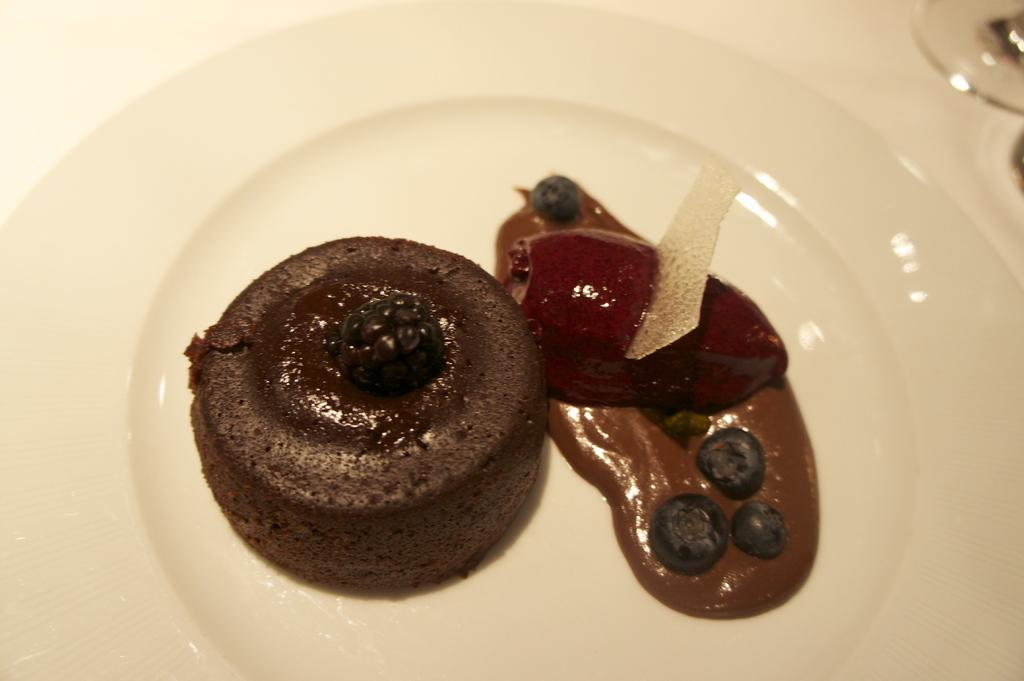What type of dessert is on the plate in the image? There is a chocolate cake on a plate in the image. What is the topping on the chocolate cake? There is chocolate cream on the cake. Where is the glass located in the image? The glass is in the top right corner of the image. On what surface is the glass placed? The glass is kept on a table. What type of clover can be seen growing near the chocolate cake in the image? There is no clover present in the image; it is a close-up of a chocolate cake with a glass in the top right corner. 